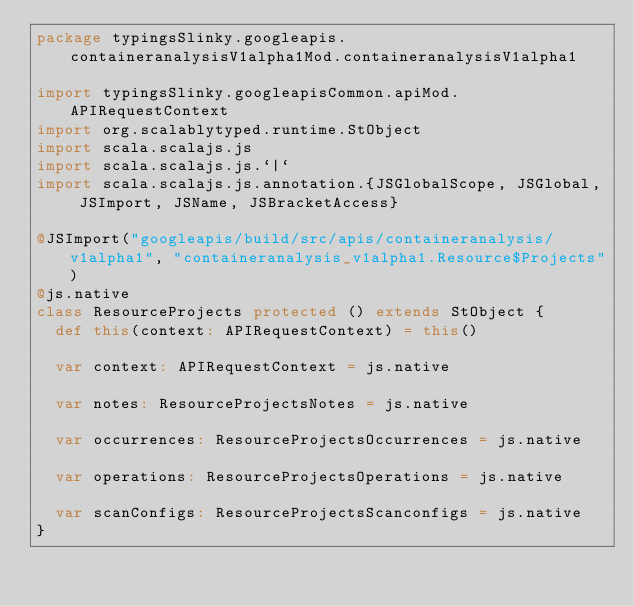Convert code to text. <code><loc_0><loc_0><loc_500><loc_500><_Scala_>package typingsSlinky.googleapis.containeranalysisV1alpha1Mod.containeranalysisV1alpha1

import typingsSlinky.googleapisCommon.apiMod.APIRequestContext
import org.scalablytyped.runtime.StObject
import scala.scalajs.js
import scala.scalajs.js.`|`
import scala.scalajs.js.annotation.{JSGlobalScope, JSGlobal, JSImport, JSName, JSBracketAccess}

@JSImport("googleapis/build/src/apis/containeranalysis/v1alpha1", "containeranalysis_v1alpha1.Resource$Projects")
@js.native
class ResourceProjects protected () extends StObject {
  def this(context: APIRequestContext) = this()
  
  var context: APIRequestContext = js.native
  
  var notes: ResourceProjectsNotes = js.native
  
  var occurrences: ResourceProjectsOccurrences = js.native
  
  var operations: ResourceProjectsOperations = js.native
  
  var scanConfigs: ResourceProjectsScanconfigs = js.native
}
</code> 